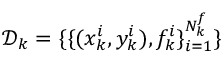<formula> <loc_0><loc_0><loc_500><loc_500>\mathcal { D } _ { k } = \{ \{ ( x _ { k } ^ { i } , y _ { k } ^ { i } ) , f _ { k } ^ { i } \} _ { i = 1 } ^ { N _ { k } ^ { f } } \}</formula> 